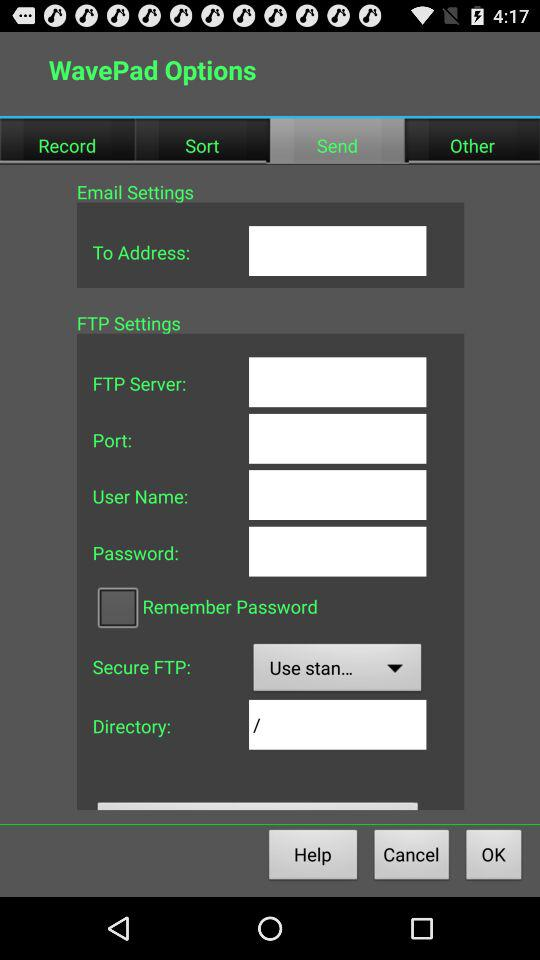Which tab is currently selected? The currently selected tab is "Send". 